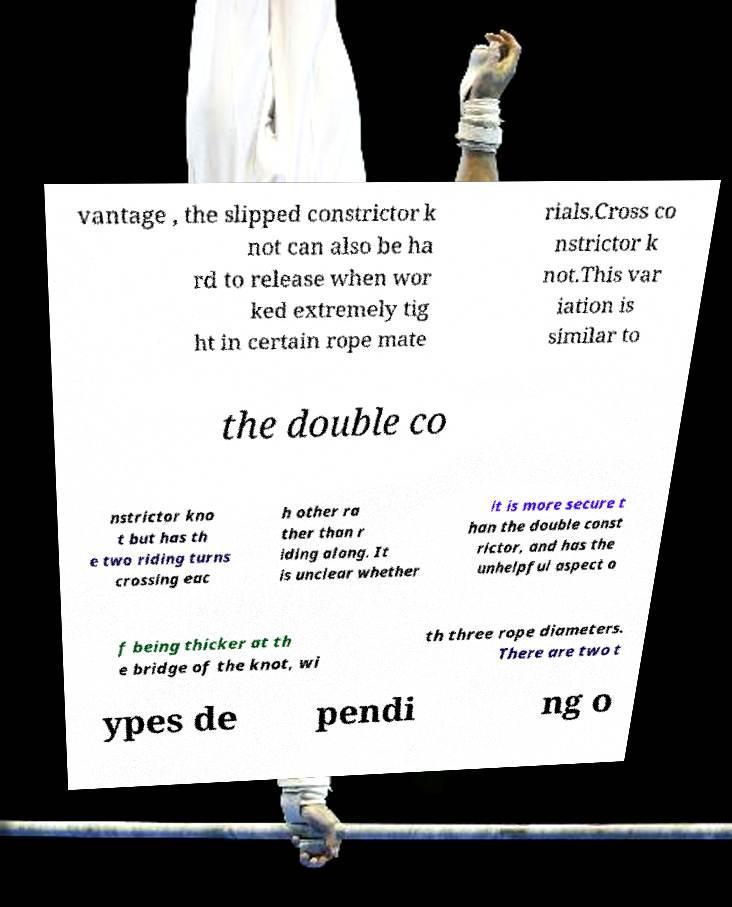Please read and relay the text visible in this image. What does it say? vantage , the slipped constrictor k not can also be ha rd to release when wor ked extremely tig ht in certain rope mate rials.Cross co nstrictor k not.This var iation is similar to the double co nstrictor kno t but has th e two riding turns crossing eac h other ra ther than r iding along. It is unclear whether it is more secure t han the double const rictor, and has the unhelpful aspect o f being thicker at th e bridge of the knot, wi th three rope diameters. There are two t ypes de pendi ng o 